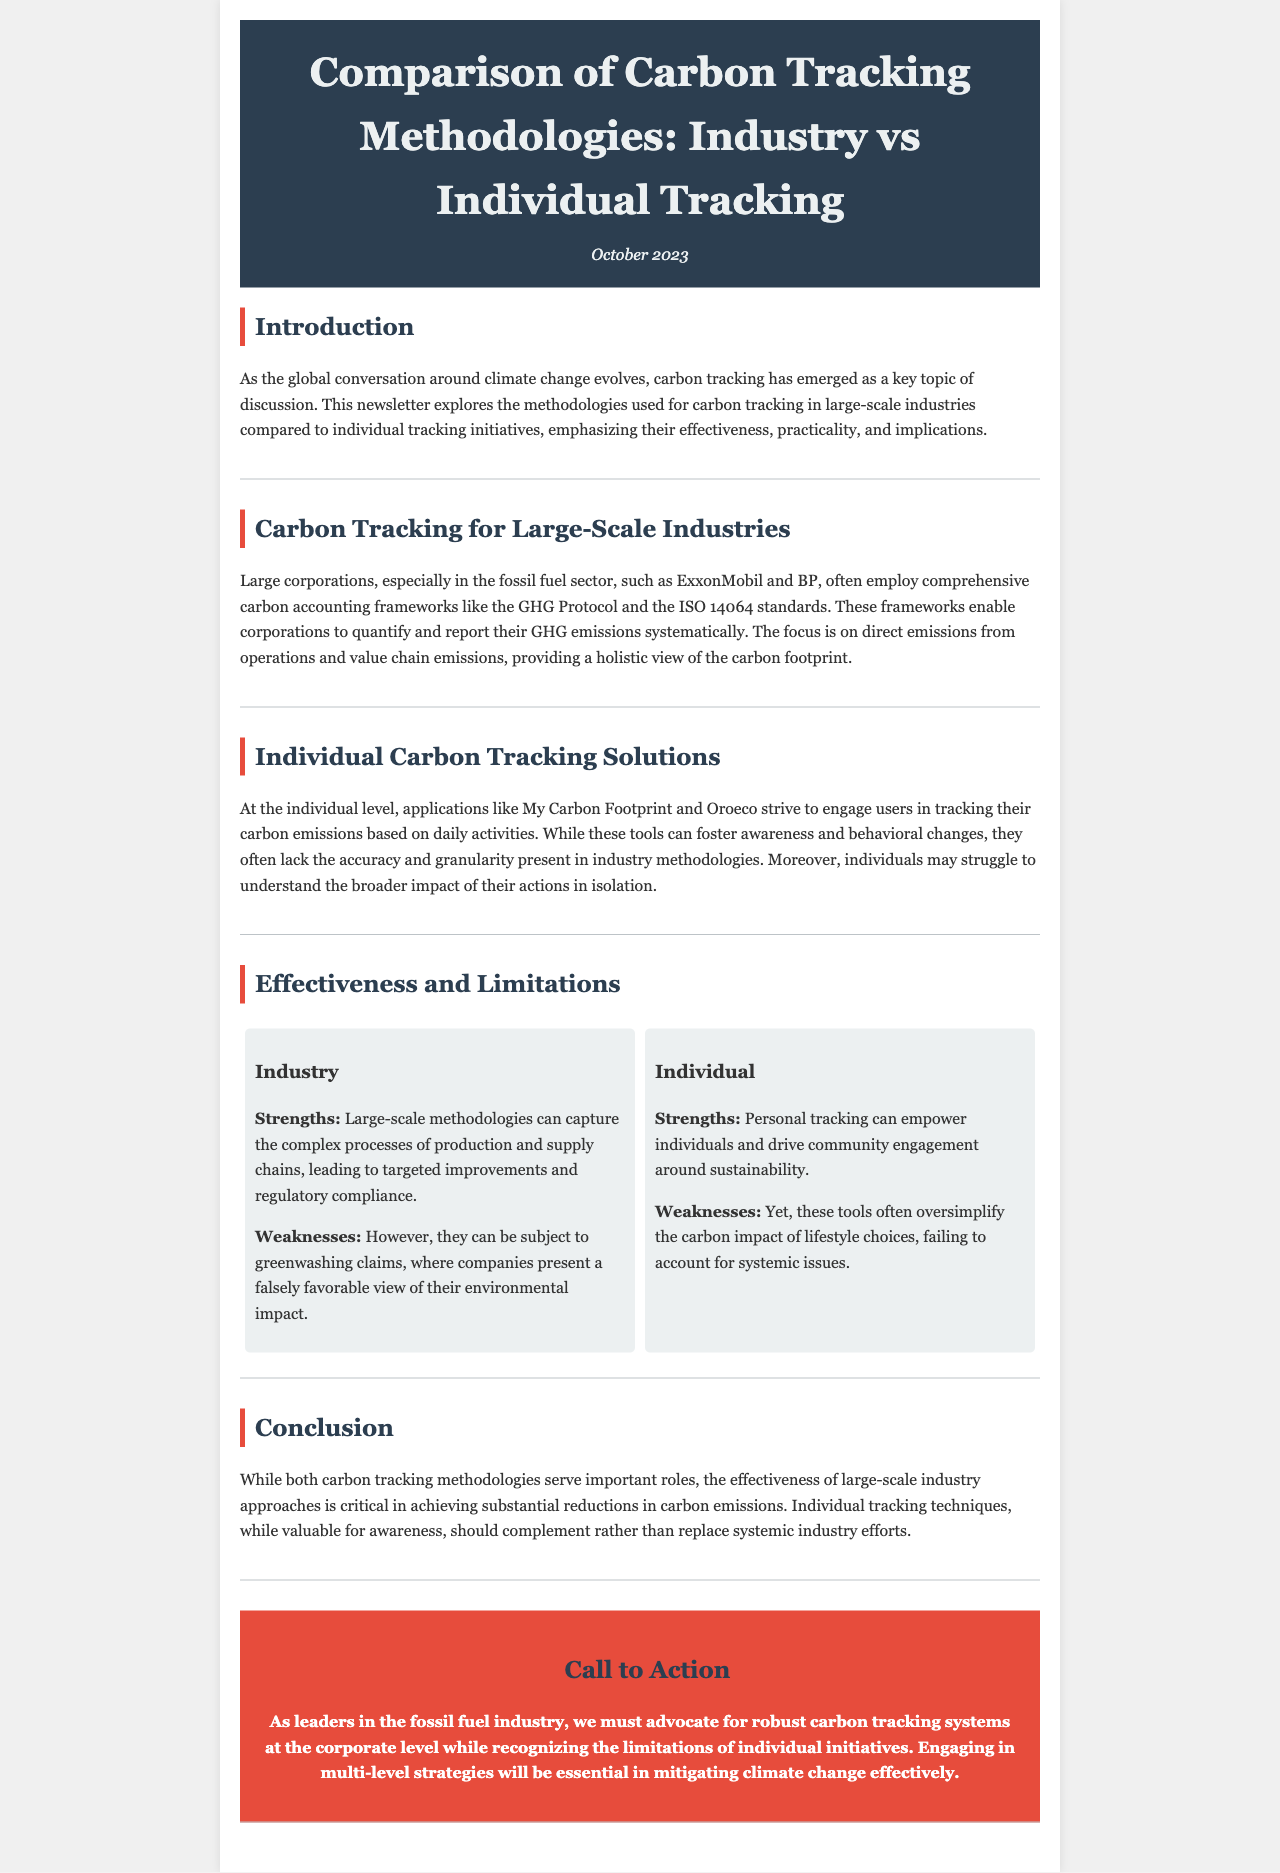What is the title of the newsletter? The title is presented in the header of the document, which is "Comparison of Carbon Tracking Methodologies: Industry vs Individual Tracking."
Answer: Comparison of Carbon Tracking Methodologies: Industry vs Individual Tracking What frameworks do large corporations often employ for carbon tracking? The frameworks mentioned for large corporations include the GHG Protocol and the ISO 14064 standards.
Answer: GHG Protocol and ISO 14064 What is a strength of individual carbon tracking solutions? One of the strengths identified for personal tracking is that it can empower individuals and drive community engagement around sustainability.
Answer: Empower individuals What are the weaknesses of industry tracking methodologies? The weaknesses discussed in the document include being subject to greenwashing claims, which means companies may present a falsely favorable view of their environmental impact.
Answer: Greenwashing claims What is the publication month and year of the newsletter? The date is noted in the header section of the document, which states October 2023.
Answer: October 2023 What role do both tracking methodologies serve? The document states that both methodologies serve important roles but emphasizes the critical nature of industry approaches in achieving substantial reductions.
Answer: Important roles What is the call to action in the newsletter? The call to action discusses the need for advocating robust carbon tracking systems at the corporate level, recognizing the limitations of individual initiatives.
Answer: Advocate for robust carbon tracking systems What is a limitation of individual carbon tracking tools? The limitations cited indicate that these tools often oversimplify the carbon impact of lifestyle choices, failing to account for systemic issues.
Answer: Oversimplify carbon impact What is the purpose of this newsletter? The purpose is to explore carbon tracking methodologies and their effectiveness in large-scale industries versus individual tracking initiatives.
Answer: Explore carbon tracking methodologies 